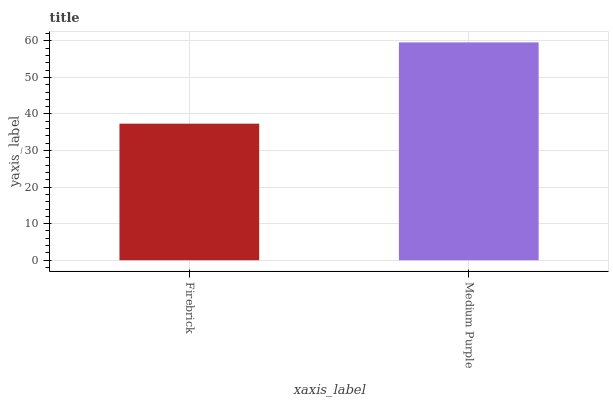Is Firebrick the minimum?
Answer yes or no. Yes. Is Medium Purple the maximum?
Answer yes or no. Yes. Is Medium Purple the minimum?
Answer yes or no. No. Is Medium Purple greater than Firebrick?
Answer yes or no. Yes. Is Firebrick less than Medium Purple?
Answer yes or no. Yes. Is Firebrick greater than Medium Purple?
Answer yes or no. No. Is Medium Purple less than Firebrick?
Answer yes or no. No. Is Medium Purple the high median?
Answer yes or no. Yes. Is Firebrick the low median?
Answer yes or no. Yes. Is Firebrick the high median?
Answer yes or no. No. Is Medium Purple the low median?
Answer yes or no. No. 